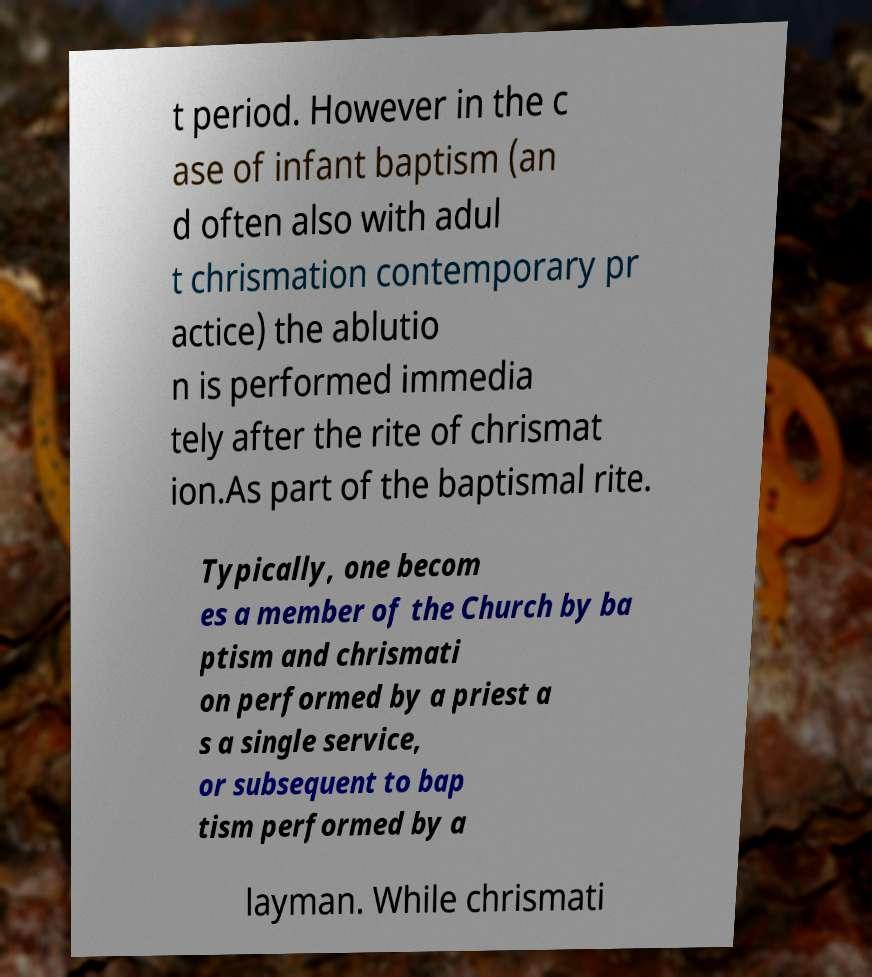For documentation purposes, I need the text within this image transcribed. Could you provide that? t period. However in the c ase of infant baptism (an d often also with adul t chrismation contemporary pr actice) the ablutio n is performed immedia tely after the rite of chrismat ion.As part of the baptismal rite. Typically, one becom es a member of the Church by ba ptism and chrismati on performed by a priest a s a single service, or subsequent to bap tism performed by a layman. While chrismati 